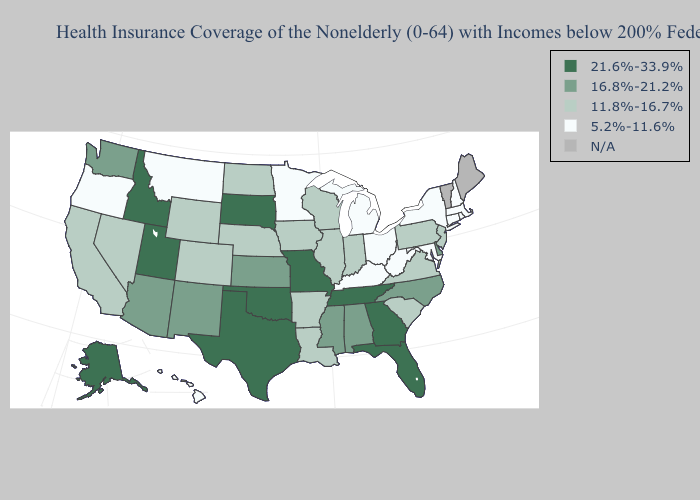Name the states that have a value in the range N/A?
Write a very short answer. Maine, Vermont. What is the highest value in states that border Montana?
Quick response, please. 21.6%-33.9%. Among the states that border California , does Nevada have the highest value?
Quick response, please. No. Name the states that have a value in the range 16.8%-21.2%?
Concise answer only. Alabama, Arizona, Delaware, Kansas, Mississippi, New Mexico, North Carolina, Washington. Which states have the lowest value in the USA?
Give a very brief answer. Connecticut, Hawaii, Kentucky, Maryland, Massachusetts, Michigan, Minnesota, Montana, New Hampshire, New York, Ohio, Oregon, Rhode Island, West Virginia. What is the highest value in the South ?
Write a very short answer. 21.6%-33.9%. Which states have the lowest value in the West?
Concise answer only. Hawaii, Montana, Oregon. What is the value of Kansas?
Give a very brief answer. 16.8%-21.2%. What is the lowest value in states that border South Dakota?
Quick response, please. 5.2%-11.6%. Which states hav the highest value in the South?
Write a very short answer. Florida, Georgia, Oklahoma, Tennessee, Texas. Which states have the lowest value in the USA?
Give a very brief answer. Connecticut, Hawaii, Kentucky, Maryland, Massachusetts, Michigan, Minnesota, Montana, New Hampshire, New York, Ohio, Oregon, Rhode Island, West Virginia. Among the states that border Utah , does Wyoming have the lowest value?
Short answer required. Yes. 